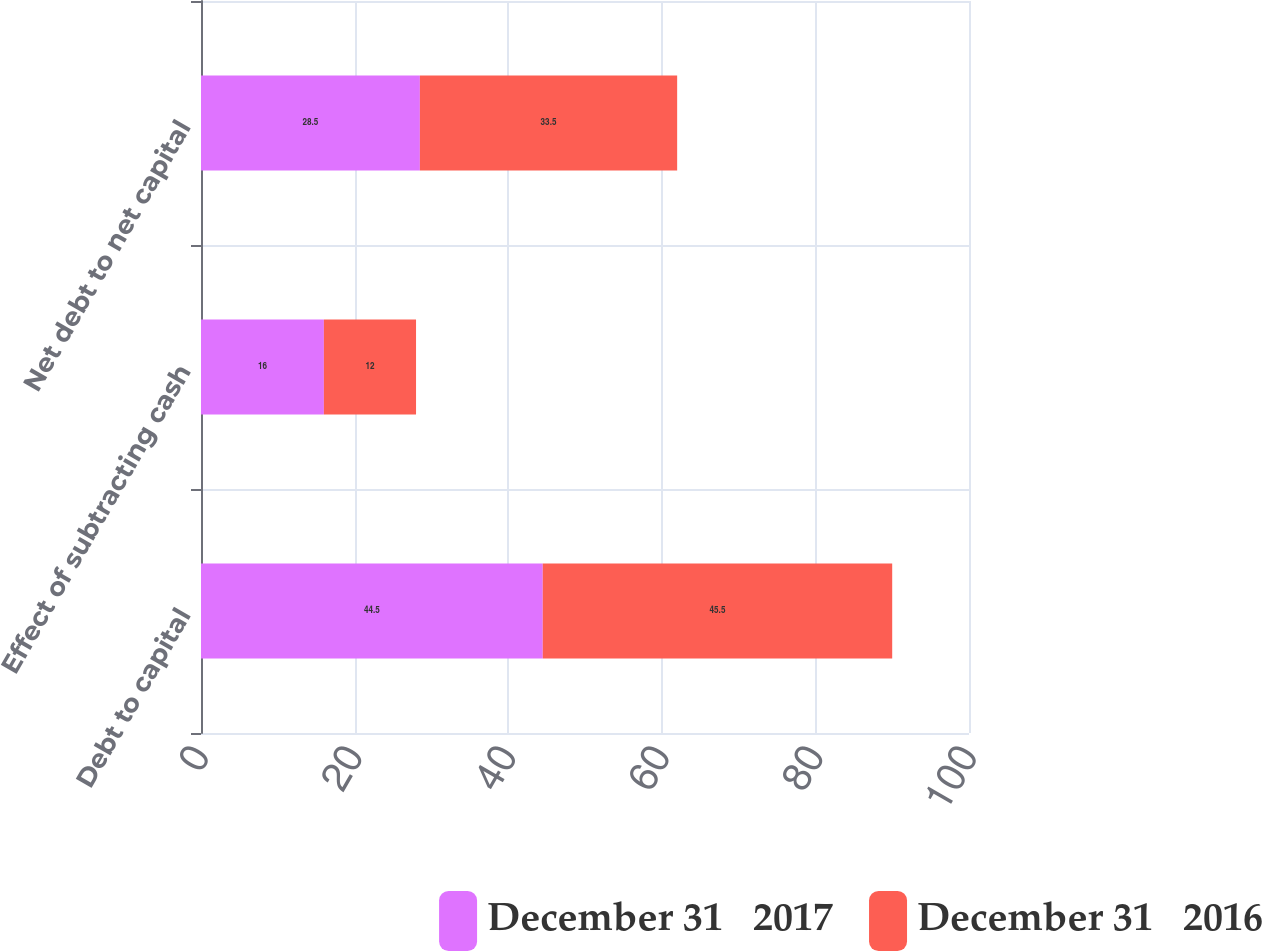Convert chart to OTSL. <chart><loc_0><loc_0><loc_500><loc_500><stacked_bar_chart><ecel><fcel>Debt to capital<fcel>Effect of subtracting cash<fcel>Net debt to net capital<nl><fcel>December 31   2017<fcel>44.5<fcel>16<fcel>28.5<nl><fcel>December 31   2016<fcel>45.5<fcel>12<fcel>33.5<nl></chart> 